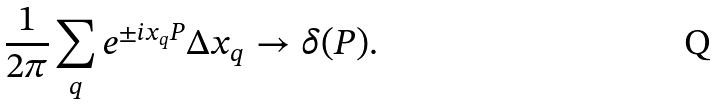Convert formula to latex. <formula><loc_0><loc_0><loc_500><loc_500>\frac { 1 } { 2 \pi } \sum _ { q } e ^ { \pm i x _ { q } P } \Delta x _ { q } \to \delta ( P ) .</formula> 